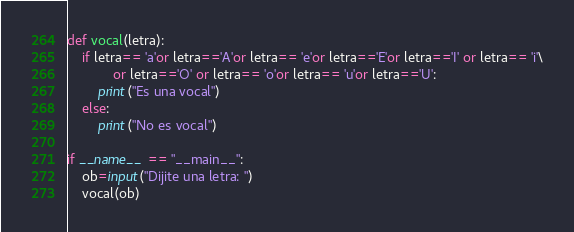<code> <loc_0><loc_0><loc_500><loc_500><_Python_>def vocal(letra):
    if letra== 'a'or letra=='A'or letra== 'e'or letra=='E'or letra=='I' or letra== 'i'\
            or letra=='O' or letra== 'o'or letra== 'u'or letra=='U':
        print("Es una vocal")
    else:
        print("No es vocal")

if __name__ == "__main__":
    ob=input("Dijite una letra: ")
    vocal(ob)
</code> 